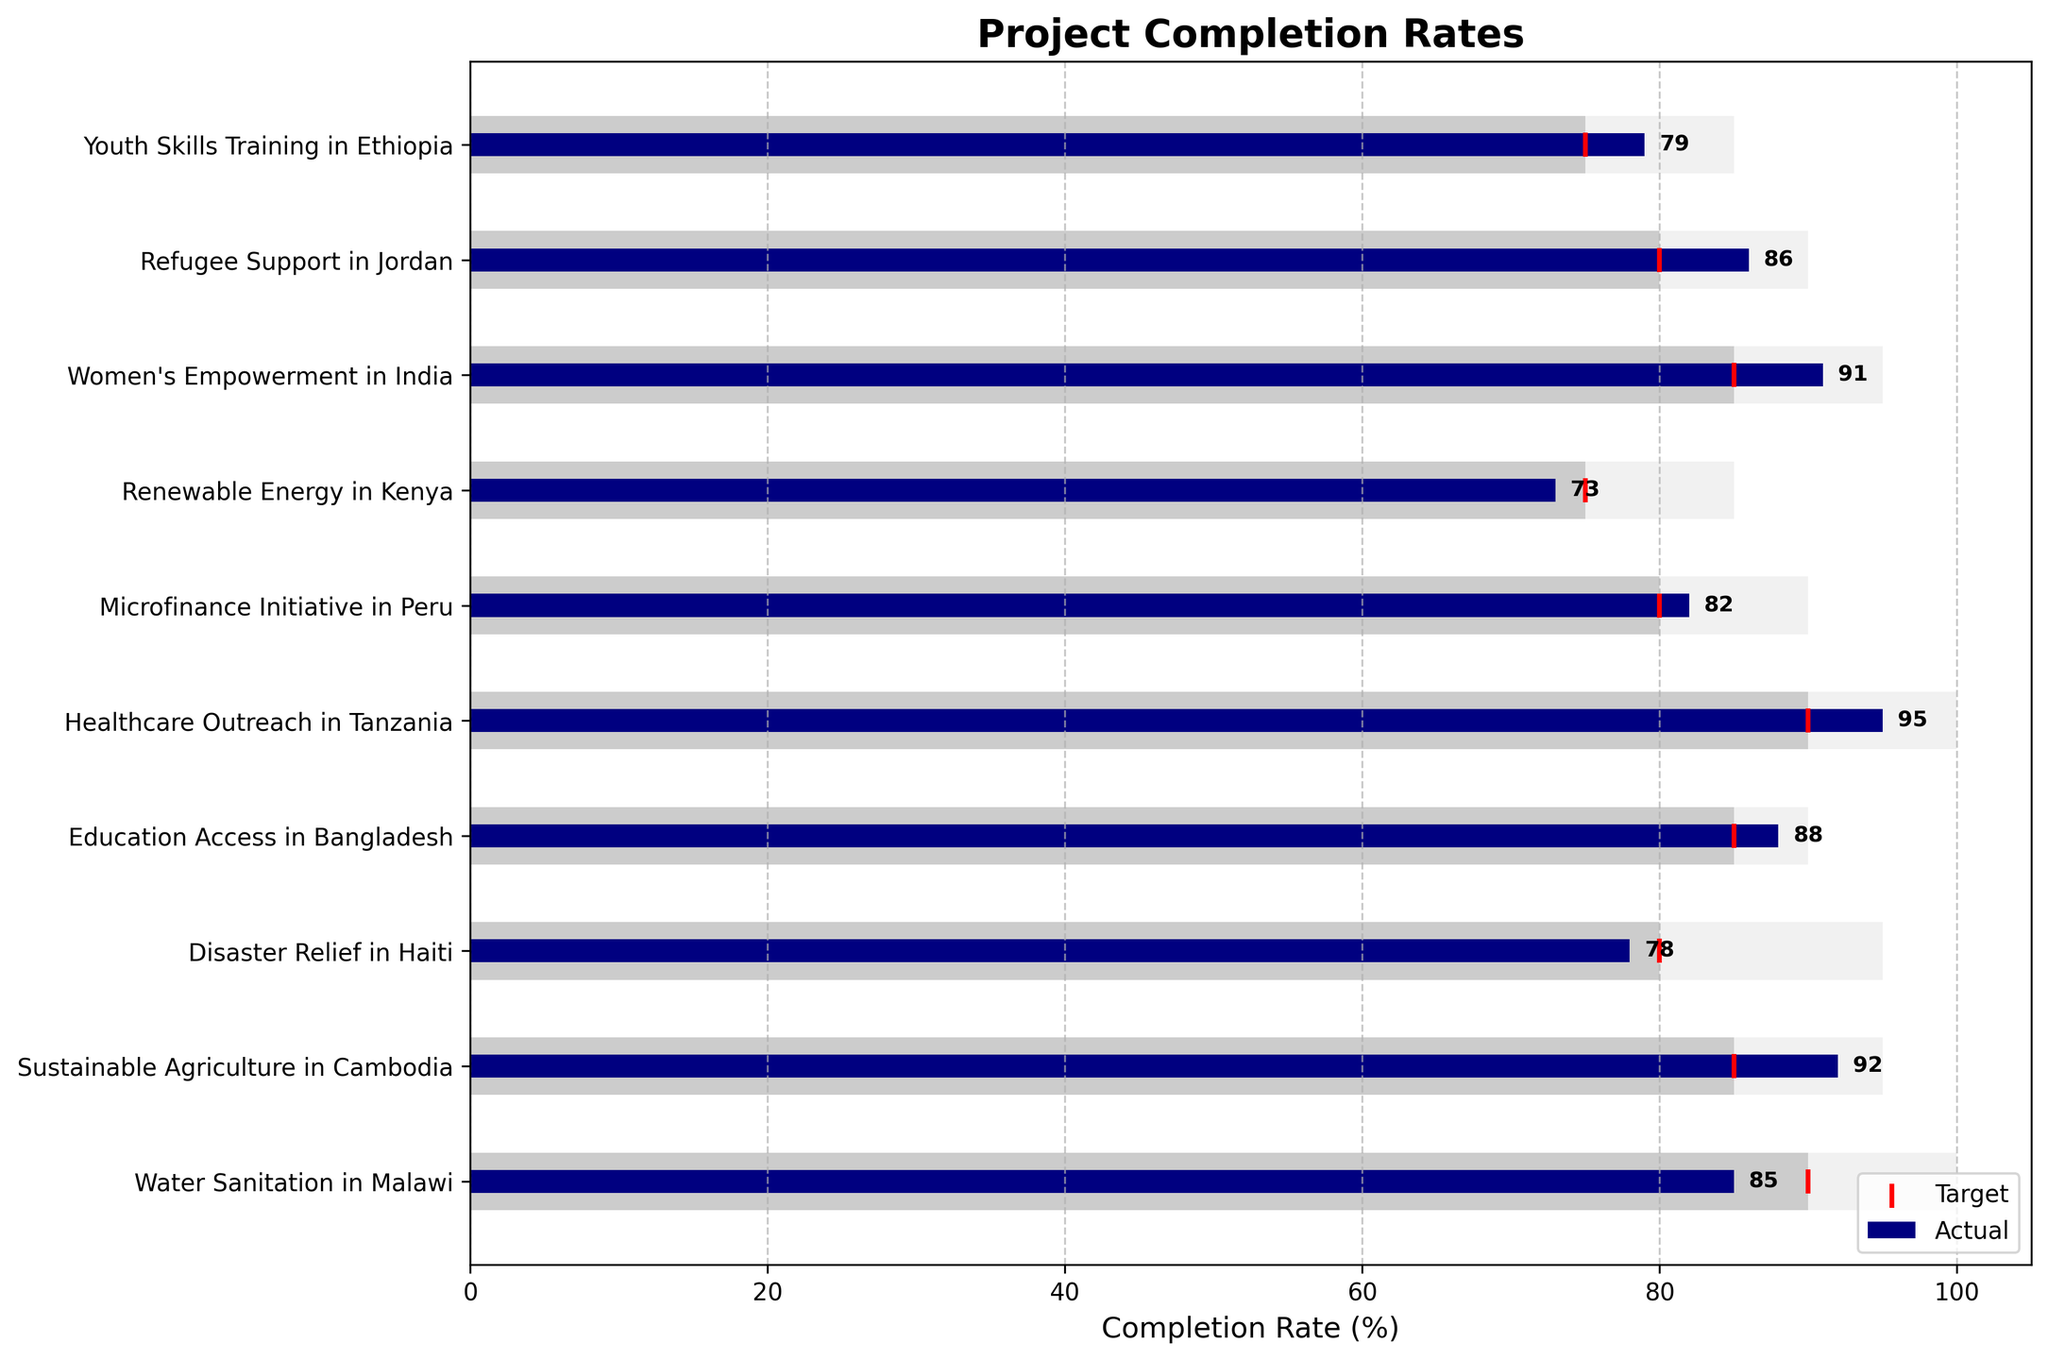What is the title of the chart? The title of the chart is displayed prominently above the chart area in bold text.
Answer: Project Completion Rates Which project has the highest actual completion rate? The highest actual completion rate bar is the longest navy-colored bar in the chart.
Answer: Healthcare Outreach in Tanzania How many projects exceeded their target completion rate? Count the bars for which the actual completion rate goes beyond the red target marker.
Answer: 6 projects What is the difference between the actual completion rate and the target completion rate for Women's Empowerment in India? Subtract the target completion rate from the actual completion rate for Women's Empowerment in India (91 - 85).
Answer: 6% Which project has the lowest stretch goal? The smallest stretch goal bar among all the light gray bars corresponds to Youth Skills Training in Ethiopia.
Answer: Youth Skills Training in Ethiopia How many projects did not meet their target completion rate? Count the number of projects where the navy-colored actual completion rate bar is shorter than the red target marker.
Answer: 4 projects Which project came closest to meeting its target without exceeding it? Identify the bar that is closest to the red target marker without surpassing it.
Answer: Disaster Relief in Haiti What is the average actual completion rate across all projects? Sum all the actual completion rates and divide by the number of projects: (85 + 92 + 78 + 88 + 95 + 82 + 73 + 91 + 86 + 79) / 10 = 849 / 10.
Answer: 84.9% For which projects is the stretch goal equal to 100%? Identify the projects with light gray bars reaching up to 100%.
Answer: Water Sanitation in Malawi, Healthcare Outreach in Tanzania Which project has the biggest discrepancy between its actual completion rate and its stretch goal? Find the difference between the actual completion rate and the stretch goal for each project and identify the maximum difference. Disaster Relief in Haiti has discrepancies (95 - 78) = 17%.
Answer: Disaster Relief in Haiti 